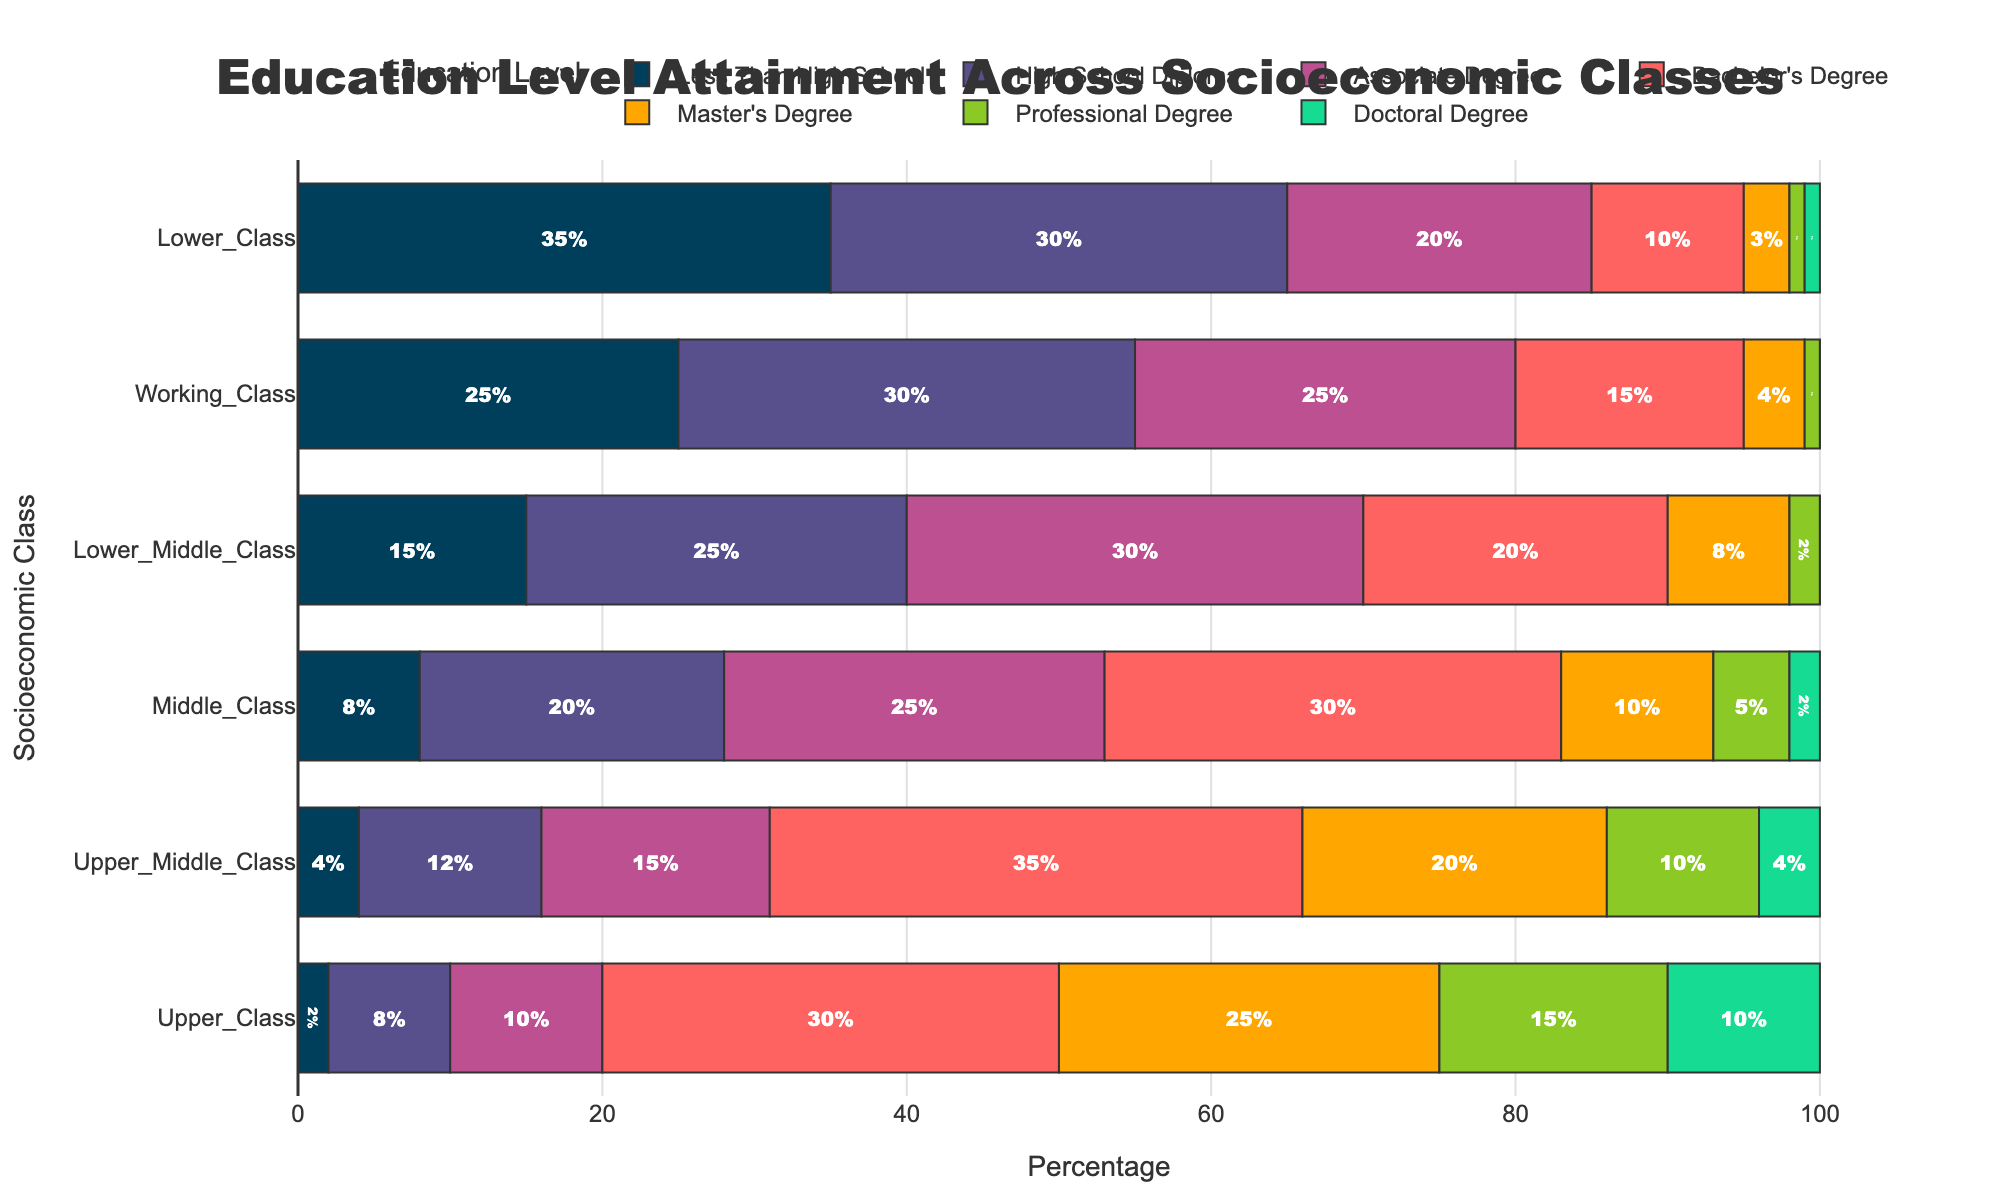What's the percentage of people with a Bachelor's degree in the Working Class? Refer to the section of the bar chart labeled "Working Class" and look at the segment for "Bachelor's Degree." It indicates a percentage of 15%.
Answer: 15% Which socioeconomic class has the highest percentage of people with less than a high school education? Look at the bar segments for "Less Than High School" across all classes. The "Lower Class" has the longest bar in this category, indicating the highest percentage at 35%.
Answer: Lower Class How does the percentage of Master's degree holders compare between the Upper Class and the Lower Class? Examine the segments for "Master's Degree" for both Upper and Lower Class. The Upper Class shows 25% while the Lower Class shows 3%. Therefore, the Upper Class has a significantly higher percentage.
Answer: Upper Class has a higher percentage What's the total percentage of people with at least a Bachelor's degree in the Upper Middle Class? To find this, sum the percentages of people with a Bachelor's degree, Master's degree, Professional degree, and Doctoral degree in the Upper Middle Class: 35% + 20% + 10% + 4% = 69%.
Answer: 69% Which socioeconomic class shows the least percentage in the Professional Degree category? Look at the segments for "Professional Degree" across all classes. Both the Lower Class and Lower Middle Class have minimal segments of 1%.
Answer: Lower Class and Lower Middle Class What is the visual pattern of educational attainment levels in the Lower Middle Class versus the Middle Class? Compare the lengths of each bar segment for the Lower Middle Class and Middle Class. The Lower Middle Class has longer segments in the lower educational categories and shorter segments in higher degrees, while the Middle Class shows a more balanced distribution across the levels.
Answer: Lower Middle Class has more in lower levels, Middle Class is more balanced Calculate the average percentage of people with a Doctoral degree across all socioeconomic classes. Add up the percentages for Doctoral degrees across all classes: 10% + 4% + 2% + 0% + 0% + 1% = 17%. Divide by the number of classes (6): 17% / 6 ≈ 2.83%.
Answer: Approximately 2.83% Which class shows the most diverse distribution of education attainment levels? Look for the class where the bar segments show the most variation in length. The Upper Class has a diverse distribution with significant percentages in almost all categories except for the lowest one.
Answer: Upper Class What's the percentage difference in people with an Associate degree between the Lower Middle Class and Upper Middle Class? The Associate degree percentage for the Lower Middle Class is 30%, and for the Upper Middle Class, it is 15%. The difference is 30% - 15% = 15%.
Answer: 15% 